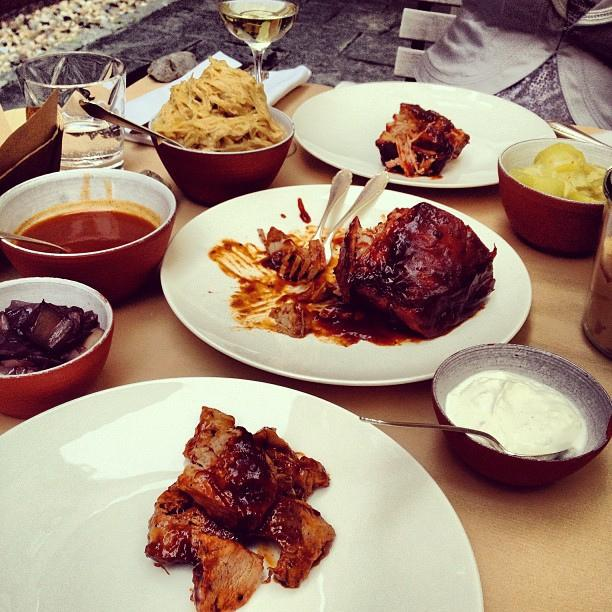What type feast is being served here?

Choices:
A) burger grill
B) barbeque
C) fish fry
D) clam bake barbeque 